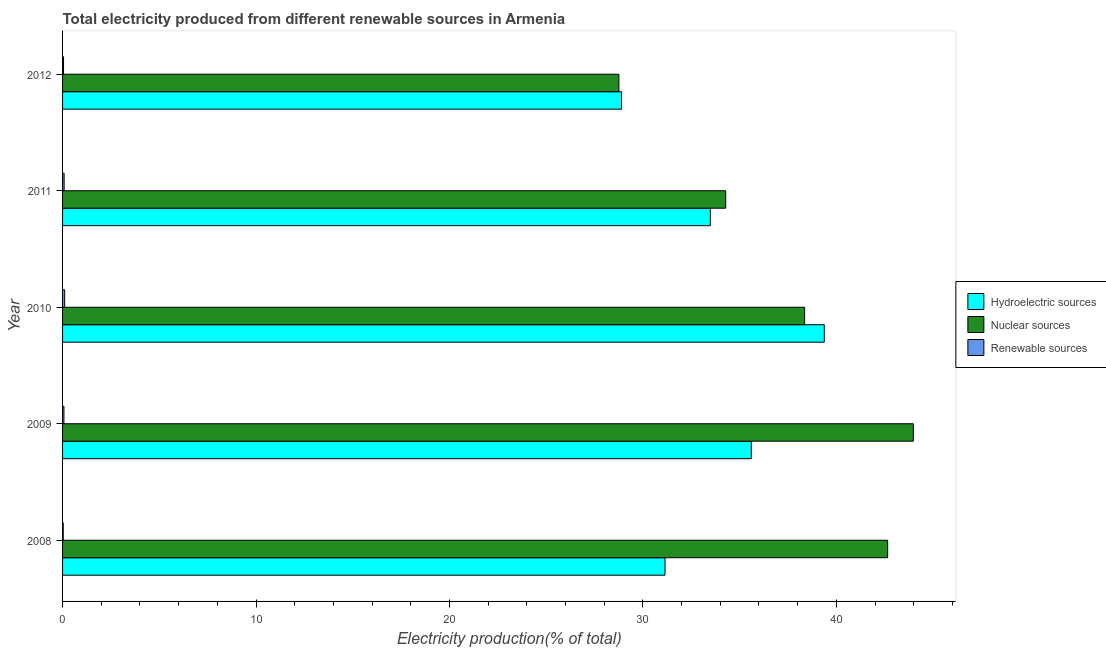How many different coloured bars are there?
Ensure brevity in your answer.  3. Are the number of bars per tick equal to the number of legend labels?
Provide a succinct answer. Yes. How many bars are there on the 2nd tick from the top?
Your answer should be very brief. 3. How many bars are there on the 5th tick from the bottom?
Your response must be concise. 3. What is the percentage of electricity produced by renewable sources in 2010?
Make the answer very short. 0.11. Across all years, what is the maximum percentage of electricity produced by renewable sources?
Provide a succinct answer. 0.11. Across all years, what is the minimum percentage of electricity produced by nuclear sources?
Make the answer very short. 28.76. In which year was the percentage of electricity produced by renewable sources minimum?
Your answer should be very brief. 2008. What is the total percentage of electricity produced by hydroelectric sources in the graph?
Give a very brief answer. 168.5. What is the difference between the percentage of electricity produced by nuclear sources in 2011 and that in 2012?
Make the answer very short. 5.52. What is the difference between the percentage of electricity produced by nuclear sources in 2010 and the percentage of electricity produced by renewable sources in 2011?
Keep it short and to the point. 38.28. What is the average percentage of electricity produced by renewable sources per year?
Keep it short and to the point. 0.07. In the year 2010, what is the difference between the percentage of electricity produced by renewable sources and percentage of electricity produced by hydroelectric sources?
Keep it short and to the point. -39.27. In how many years, is the percentage of electricity produced by nuclear sources greater than 44 %?
Your response must be concise. 0. What is the ratio of the percentage of electricity produced by renewable sources in 2008 to that in 2012?
Your response must be concise. 0.7. Is the percentage of electricity produced by nuclear sources in 2008 less than that in 2010?
Give a very brief answer. No. What is the difference between the highest and the second highest percentage of electricity produced by nuclear sources?
Your answer should be very brief. 1.33. What is the difference between the highest and the lowest percentage of electricity produced by hydroelectric sources?
Provide a short and direct response. 10.48. What does the 1st bar from the top in 2009 represents?
Offer a terse response. Renewable sources. What does the 3rd bar from the bottom in 2011 represents?
Your answer should be compact. Renewable sources. How many years are there in the graph?
Ensure brevity in your answer.  5. Does the graph contain any zero values?
Keep it short and to the point. No. Does the graph contain grids?
Keep it short and to the point. No. Where does the legend appear in the graph?
Your response must be concise. Center right. How are the legend labels stacked?
Provide a succinct answer. Vertical. What is the title of the graph?
Provide a short and direct response. Total electricity produced from different renewable sources in Armenia. Does "Self-employed" appear as one of the legend labels in the graph?
Ensure brevity in your answer.  No. What is the label or title of the X-axis?
Make the answer very short. Electricity production(% of total). What is the Electricity production(% of total) in Hydroelectric sources in 2008?
Provide a short and direct response. 31.14. What is the Electricity production(% of total) of Nuclear sources in 2008?
Ensure brevity in your answer.  42.65. What is the Electricity production(% of total) of Renewable sources in 2008?
Your answer should be compact. 0.03. What is the Electricity production(% of total) of Hydroelectric sources in 2009?
Offer a very short reply. 35.6. What is the Electricity production(% of total) of Nuclear sources in 2009?
Make the answer very short. 43.98. What is the Electricity production(% of total) of Renewable sources in 2009?
Your answer should be compact. 0.07. What is the Electricity production(% of total) in Hydroelectric sources in 2010?
Ensure brevity in your answer.  39.38. What is the Electricity production(% of total) of Nuclear sources in 2010?
Give a very brief answer. 38.36. What is the Electricity production(% of total) in Renewable sources in 2010?
Ensure brevity in your answer.  0.11. What is the Electricity production(% of total) of Hydroelectric sources in 2011?
Offer a very short reply. 33.49. What is the Electricity production(% of total) of Nuclear sources in 2011?
Provide a succinct answer. 34.28. What is the Electricity production(% of total) in Renewable sources in 2011?
Your response must be concise. 0.08. What is the Electricity production(% of total) of Hydroelectric sources in 2012?
Make the answer very short. 28.89. What is the Electricity production(% of total) in Nuclear sources in 2012?
Provide a succinct answer. 28.76. What is the Electricity production(% of total) of Renewable sources in 2012?
Offer a very short reply. 0.05. Across all years, what is the maximum Electricity production(% of total) in Hydroelectric sources?
Offer a very short reply. 39.38. Across all years, what is the maximum Electricity production(% of total) of Nuclear sources?
Offer a very short reply. 43.98. Across all years, what is the maximum Electricity production(% of total) in Renewable sources?
Provide a succinct answer. 0.11. Across all years, what is the minimum Electricity production(% of total) of Hydroelectric sources?
Keep it short and to the point. 28.89. Across all years, what is the minimum Electricity production(% of total) of Nuclear sources?
Provide a succinct answer. 28.76. Across all years, what is the minimum Electricity production(% of total) of Renewable sources?
Provide a succinct answer. 0.03. What is the total Electricity production(% of total) in Hydroelectric sources in the graph?
Provide a short and direct response. 168.5. What is the total Electricity production(% of total) in Nuclear sources in the graph?
Your response must be concise. 188.03. What is the total Electricity production(% of total) of Renewable sources in the graph?
Your response must be concise. 0.34. What is the difference between the Electricity production(% of total) in Hydroelectric sources in 2008 and that in 2009?
Your answer should be very brief. -4.46. What is the difference between the Electricity production(% of total) in Nuclear sources in 2008 and that in 2009?
Offer a very short reply. -1.33. What is the difference between the Electricity production(% of total) of Renewable sources in 2008 and that in 2009?
Offer a terse response. -0.04. What is the difference between the Electricity production(% of total) in Hydroelectric sources in 2008 and that in 2010?
Provide a succinct answer. -8.23. What is the difference between the Electricity production(% of total) in Nuclear sources in 2008 and that in 2010?
Keep it short and to the point. 4.29. What is the difference between the Electricity production(% of total) in Renewable sources in 2008 and that in 2010?
Your answer should be compact. -0.07. What is the difference between the Electricity production(% of total) of Hydroelectric sources in 2008 and that in 2011?
Provide a succinct answer. -2.34. What is the difference between the Electricity production(% of total) in Nuclear sources in 2008 and that in 2011?
Your answer should be very brief. 8.37. What is the difference between the Electricity production(% of total) of Renewable sources in 2008 and that in 2011?
Provide a short and direct response. -0.05. What is the difference between the Electricity production(% of total) in Hydroelectric sources in 2008 and that in 2012?
Make the answer very short. 2.25. What is the difference between the Electricity production(% of total) of Nuclear sources in 2008 and that in 2012?
Provide a succinct answer. 13.89. What is the difference between the Electricity production(% of total) of Renewable sources in 2008 and that in 2012?
Offer a terse response. -0.02. What is the difference between the Electricity production(% of total) in Hydroelectric sources in 2009 and that in 2010?
Make the answer very short. -3.78. What is the difference between the Electricity production(% of total) in Nuclear sources in 2009 and that in 2010?
Make the answer very short. 5.62. What is the difference between the Electricity production(% of total) of Renewable sources in 2009 and that in 2010?
Keep it short and to the point. -0.04. What is the difference between the Electricity production(% of total) of Hydroelectric sources in 2009 and that in 2011?
Give a very brief answer. 2.12. What is the difference between the Electricity production(% of total) in Nuclear sources in 2009 and that in 2011?
Offer a very short reply. 9.7. What is the difference between the Electricity production(% of total) in Renewable sources in 2009 and that in 2011?
Offer a very short reply. -0.01. What is the difference between the Electricity production(% of total) of Hydroelectric sources in 2009 and that in 2012?
Make the answer very short. 6.71. What is the difference between the Electricity production(% of total) of Nuclear sources in 2009 and that in 2012?
Ensure brevity in your answer.  15.22. What is the difference between the Electricity production(% of total) in Renewable sources in 2009 and that in 2012?
Offer a terse response. 0.02. What is the difference between the Electricity production(% of total) in Hydroelectric sources in 2010 and that in 2011?
Offer a very short reply. 5.89. What is the difference between the Electricity production(% of total) in Nuclear sources in 2010 and that in 2011?
Offer a very short reply. 4.08. What is the difference between the Electricity production(% of total) of Renewable sources in 2010 and that in 2011?
Offer a terse response. 0.03. What is the difference between the Electricity production(% of total) in Hydroelectric sources in 2010 and that in 2012?
Offer a terse response. 10.48. What is the difference between the Electricity production(% of total) of Nuclear sources in 2010 and that in 2012?
Offer a very short reply. 9.6. What is the difference between the Electricity production(% of total) in Renewable sources in 2010 and that in 2012?
Your answer should be very brief. 0.06. What is the difference between the Electricity production(% of total) in Hydroelectric sources in 2011 and that in 2012?
Provide a succinct answer. 4.59. What is the difference between the Electricity production(% of total) of Nuclear sources in 2011 and that in 2012?
Offer a terse response. 5.52. What is the difference between the Electricity production(% of total) in Renewable sources in 2011 and that in 2012?
Your answer should be very brief. 0.03. What is the difference between the Electricity production(% of total) of Hydroelectric sources in 2008 and the Electricity production(% of total) of Nuclear sources in 2009?
Give a very brief answer. -12.83. What is the difference between the Electricity production(% of total) in Hydroelectric sources in 2008 and the Electricity production(% of total) in Renewable sources in 2009?
Give a very brief answer. 31.07. What is the difference between the Electricity production(% of total) in Nuclear sources in 2008 and the Electricity production(% of total) in Renewable sources in 2009?
Your response must be concise. 42.58. What is the difference between the Electricity production(% of total) in Hydroelectric sources in 2008 and the Electricity production(% of total) in Nuclear sources in 2010?
Your answer should be compact. -7.22. What is the difference between the Electricity production(% of total) in Hydroelectric sources in 2008 and the Electricity production(% of total) in Renewable sources in 2010?
Your answer should be very brief. 31.04. What is the difference between the Electricity production(% of total) of Nuclear sources in 2008 and the Electricity production(% of total) of Renewable sources in 2010?
Make the answer very short. 42.54. What is the difference between the Electricity production(% of total) in Hydroelectric sources in 2008 and the Electricity production(% of total) in Nuclear sources in 2011?
Provide a short and direct response. -3.14. What is the difference between the Electricity production(% of total) of Hydroelectric sources in 2008 and the Electricity production(% of total) of Renewable sources in 2011?
Keep it short and to the point. 31.06. What is the difference between the Electricity production(% of total) of Nuclear sources in 2008 and the Electricity production(% of total) of Renewable sources in 2011?
Give a very brief answer. 42.57. What is the difference between the Electricity production(% of total) of Hydroelectric sources in 2008 and the Electricity production(% of total) of Nuclear sources in 2012?
Ensure brevity in your answer.  2.39. What is the difference between the Electricity production(% of total) of Hydroelectric sources in 2008 and the Electricity production(% of total) of Renewable sources in 2012?
Your response must be concise. 31.09. What is the difference between the Electricity production(% of total) in Nuclear sources in 2008 and the Electricity production(% of total) in Renewable sources in 2012?
Provide a succinct answer. 42.6. What is the difference between the Electricity production(% of total) of Hydroelectric sources in 2009 and the Electricity production(% of total) of Nuclear sources in 2010?
Provide a short and direct response. -2.76. What is the difference between the Electricity production(% of total) in Hydroelectric sources in 2009 and the Electricity production(% of total) in Renewable sources in 2010?
Your answer should be compact. 35.49. What is the difference between the Electricity production(% of total) of Nuclear sources in 2009 and the Electricity production(% of total) of Renewable sources in 2010?
Your answer should be compact. 43.87. What is the difference between the Electricity production(% of total) in Hydroelectric sources in 2009 and the Electricity production(% of total) in Nuclear sources in 2011?
Your response must be concise. 1.32. What is the difference between the Electricity production(% of total) in Hydroelectric sources in 2009 and the Electricity production(% of total) in Renewable sources in 2011?
Your response must be concise. 35.52. What is the difference between the Electricity production(% of total) of Nuclear sources in 2009 and the Electricity production(% of total) of Renewable sources in 2011?
Ensure brevity in your answer.  43.9. What is the difference between the Electricity production(% of total) in Hydroelectric sources in 2009 and the Electricity production(% of total) in Nuclear sources in 2012?
Offer a very short reply. 6.84. What is the difference between the Electricity production(% of total) of Hydroelectric sources in 2009 and the Electricity production(% of total) of Renewable sources in 2012?
Your answer should be compact. 35.55. What is the difference between the Electricity production(% of total) of Nuclear sources in 2009 and the Electricity production(% of total) of Renewable sources in 2012?
Ensure brevity in your answer.  43.93. What is the difference between the Electricity production(% of total) in Hydroelectric sources in 2010 and the Electricity production(% of total) in Nuclear sources in 2011?
Keep it short and to the point. 5.1. What is the difference between the Electricity production(% of total) in Hydroelectric sources in 2010 and the Electricity production(% of total) in Renewable sources in 2011?
Your answer should be compact. 39.3. What is the difference between the Electricity production(% of total) in Nuclear sources in 2010 and the Electricity production(% of total) in Renewable sources in 2011?
Your answer should be very brief. 38.28. What is the difference between the Electricity production(% of total) in Hydroelectric sources in 2010 and the Electricity production(% of total) in Nuclear sources in 2012?
Offer a terse response. 10.62. What is the difference between the Electricity production(% of total) of Hydroelectric sources in 2010 and the Electricity production(% of total) of Renewable sources in 2012?
Ensure brevity in your answer.  39.33. What is the difference between the Electricity production(% of total) in Nuclear sources in 2010 and the Electricity production(% of total) in Renewable sources in 2012?
Ensure brevity in your answer.  38.31. What is the difference between the Electricity production(% of total) in Hydroelectric sources in 2011 and the Electricity production(% of total) in Nuclear sources in 2012?
Offer a very short reply. 4.73. What is the difference between the Electricity production(% of total) of Hydroelectric sources in 2011 and the Electricity production(% of total) of Renewable sources in 2012?
Your response must be concise. 33.44. What is the difference between the Electricity production(% of total) of Nuclear sources in 2011 and the Electricity production(% of total) of Renewable sources in 2012?
Provide a short and direct response. 34.23. What is the average Electricity production(% of total) of Hydroelectric sources per year?
Keep it short and to the point. 33.7. What is the average Electricity production(% of total) in Nuclear sources per year?
Your answer should be very brief. 37.61. What is the average Electricity production(% of total) of Renewable sources per year?
Provide a short and direct response. 0.07. In the year 2008, what is the difference between the Electricity production(% of total) in Hydroelectric sources and Electricity production(% of total) in Nuclear sources?
Provide a succinct answer. -11.51. In the year 2008, what is the difference between the Electricity production(% of total) of Hydroelectric sources and Electricity production(% of total) of Renewable sources?
Keep it short and to the point. 31.11. In the year 2008, what is the difference between the Electricity production(% of total) in Nuclear sources and Electricity production(% of total) in Renewable sources?
Offer a very short reply. 42.62. In the year 2009, what is the difference between the Electricity production(% of total) of Hydroelectric sources and Electricity production(% of total) of Nuclear sources?
Offer a very short reply. -8.38. In the year 2009, what is the difference between the Electricity production(% of total) of Hydroelectric sources and Electricity production(% of total) of Renewable sources?
Your response must be concise. 35.53. In the year 2009, what is the difference between the Electricity production(% of total) in Nuclear sources and Electricity production(% of total) in Renewable sources?
Ensure brevity in your answer.  43.91. In the year 2010, what is the difference between the Electricity production(% of total) of Hydroelectric sources and Electricity production(% of total) of Nuclear sources?
Provide a succinct answer. 1.02. In the year 2010, what is the difference between the Electricity production(% of total) in Hydroelectric sources and Electricity production(% of total) in Renewable sources?
Offer a very short reply. 39.27. In the year 2010, what is the difference between the Electricity production(% of total) of Nuclear sources and Electricity production(% of total) of Renewable sources?
Your answer should be compact. 38.25. In the year 2011, what is the difference between the Electricity production(% of total) in Hydroelectric sources and Electricity production(% of total) in Nuclear sources?
Your response must be concise. -0.79. In the year 2011, what is the difference between the Electricity production(% of total) in Hydroelectric sources and Electricity production(% of total) in Renewable sources?
Your answer should be very brief. 33.41. In the year 2011, what is the difference between the Electricity production(% of total) in Nuclear sources and Electricity production(% of total) in Renewable sources?
Give a very brief answer. 34.2. In the year 2012, what is the difference between the Electricity production(% of total) in Hydroelectric sources and Electricity production(% of total) in Nuclear sources?
Your answer should be very brief. 0.14. In the year 2012, what is the difference between the Electricity production(% of total) of Hydroelectric sources and Electricity production(% of total) of Renewable sources?
Your answer should be very brief. 28.85. In the year 2012, what is the difference between the Electricity production(% of total) of Nuclear sources and Electricity production(% of total) of Renewable sources?
Make the answer very short. 28.71. What is the ratio of the Electricity production(% of total) in Hydroelectric sources in 2008 to that in 2009?
Make the answer very short. 0.87. What is the ratio of the Electricity production(% of total) in Nuclear sources in 2008 to that in 2009?
Ensure brevity in your answer.  0.97. What is the ratio of the Electricity production(% of total) of Renewable sources in 2008 to that in 2009?
Provide a succinct answer. 0.49. What is the ratio of the Electricity production(% of total) in Hydroelectric sources in 2008 to that in 2010?
Your response must be concise. 0.79. What is the ratio of the Electricity production(% of total) of Nuclear sources in 2008 to that in 2010?
Provide a short and direct response. 1.11. What is the ratio of the Electricity production(% of total) of Renewable sources in 2008 to that in 2010?
Give a very brief answer. 0.32. What is the ratio of the Electricity production(% of total) of Hydroelectric sources in 2008 to that in 2011?
Give a very brief answer. 0.93. What is the ratio of the Electricity production(% of total) in Nuclear sources in 2008 to that in 2011?
Keep it short and to the point. 1.24. What is the ratio of the Electricity production(% of total) of Renewable sources in 2008 to that in 2011?
Provide a short and direct response. 0.43. What is the ratio of the Electricity production(% of total) of Hydroelectric sources in 2008 to that in 2012?
Make the answer very short. 1.08. What is the ratio of the Electricity production(% of total) in Nuclear sources in 2008 to that in 2012?
Make the answer very short. 1.48. What is the ratio of the Electricity production(% of total) of Renewable sources in 2008 to that in 2012?
Give a very brief answer. 0.7. What is the ratio of the Electricity production(% of total) in Hydroelectric sources in 2009 to that in 2010?
Your answer should be very brief. 0.9. What is the ratio of the Electricity production(% of total) of Nuclear sources in 2009 to that in 2010?
Provide a succinct answer. 1.15. What is the ratio of the Electricity production(% of total) of Renewable sources in 2009 to that in 2010?
Make the answer very short. 0.65. What is the ratio of the Electricity production(% of total) of Hydroelectric sources in 2009 to that in 2011?
Offer a very short reply. 1.06. What is the ratio of the Electricity production(% of total) in Nuclear sources in 2009 to that in 2011?
Keep it short and to the point. 1.28. What is the ratio of the Electricity production(% of total) in Renewable sources in 2009 to that in 2011?
Ensure brevity in your answer.  0.87. What is the ratio of the Electricity production(% of total) in Hydroelectric sources in 2009 to that in 2012?
Your response must be concise. 1.23. What is the ratio of the Electricity production(% of total) in Nuclear sources in 2009 to that in 2012?
Keep it short and to the point. 1.53. What is the ratio of the Electricity production(% of total) in Renewable sources in 2009 to that in 2012?
Provide a succinct answer. 1.42. What is the ratio of the Electricity production(% of total) of Hydroelectric sources in 2010 to that in 2011?
Keep it short and to the point. 1.18. What is the ratio of the Electricity production(% of total) of Nuclear sources in 2010 to that in 2011?
Your answer should be compact. 1.12. What is the ratio of the Electricity production(% of total) in Renewable sources in 2010 to that in 2011?
Your answer should be compact. 1.34. What is the ratio of the Electricity production(% of total) of Hydroelectric sources in 2010 to that in 2012?
Offer a very short reply. 1.36. What is the ratio of the Electricity production(% of total) in Nuclear sources in 2010 to that in 2012?
Offer a very short reply. 1.33. What is the ratio of the Electricity production(% of total) in Renewable sources in 2010 to that in 2012?
Provide a short and direct response. 2.17. What is the ratio of the Electricity production(% of total) in Hydroelectric sources in 2011 to that in 2012?
Give a very brief answer. 1.16. What is the ratio of the Electricity production(% of total) of Nuclear sources in 2011 to that in 2012?
Ensure brevity in your answer.  1.19. What is the ratio of the Electricity production(% of total) of Renewable sources in 2011 to that in 2012?
Provide a succinct answer. 1.62. What is the difference between the highest and the second highest Electricity production(% of total) in Hydroelectric sources?
Provide a short and direct response. 3.78. What is the difference between the highest and the second highest Electricity production(% of total) in Nuclear sources?
Your answer should be very brief. 1.33. What is the difference between the highest and the second highest Electricity production(% of total) in Renewable sources?
Offer a terse response. 0.03. What is the difference between the highest and the lowest Electricity production(% of total) in Hydroelectric sources?
Provide a succinct answer. 10.48. What is the difference between the highest and the lowest Electricity production(% of total) of Nuclear sources?
Keep it short and to the point. 15.22. What is the difference between the highest and the lowest Electricity production(% of total) of Renewable sources?
Make the answer very short. 0.07. 